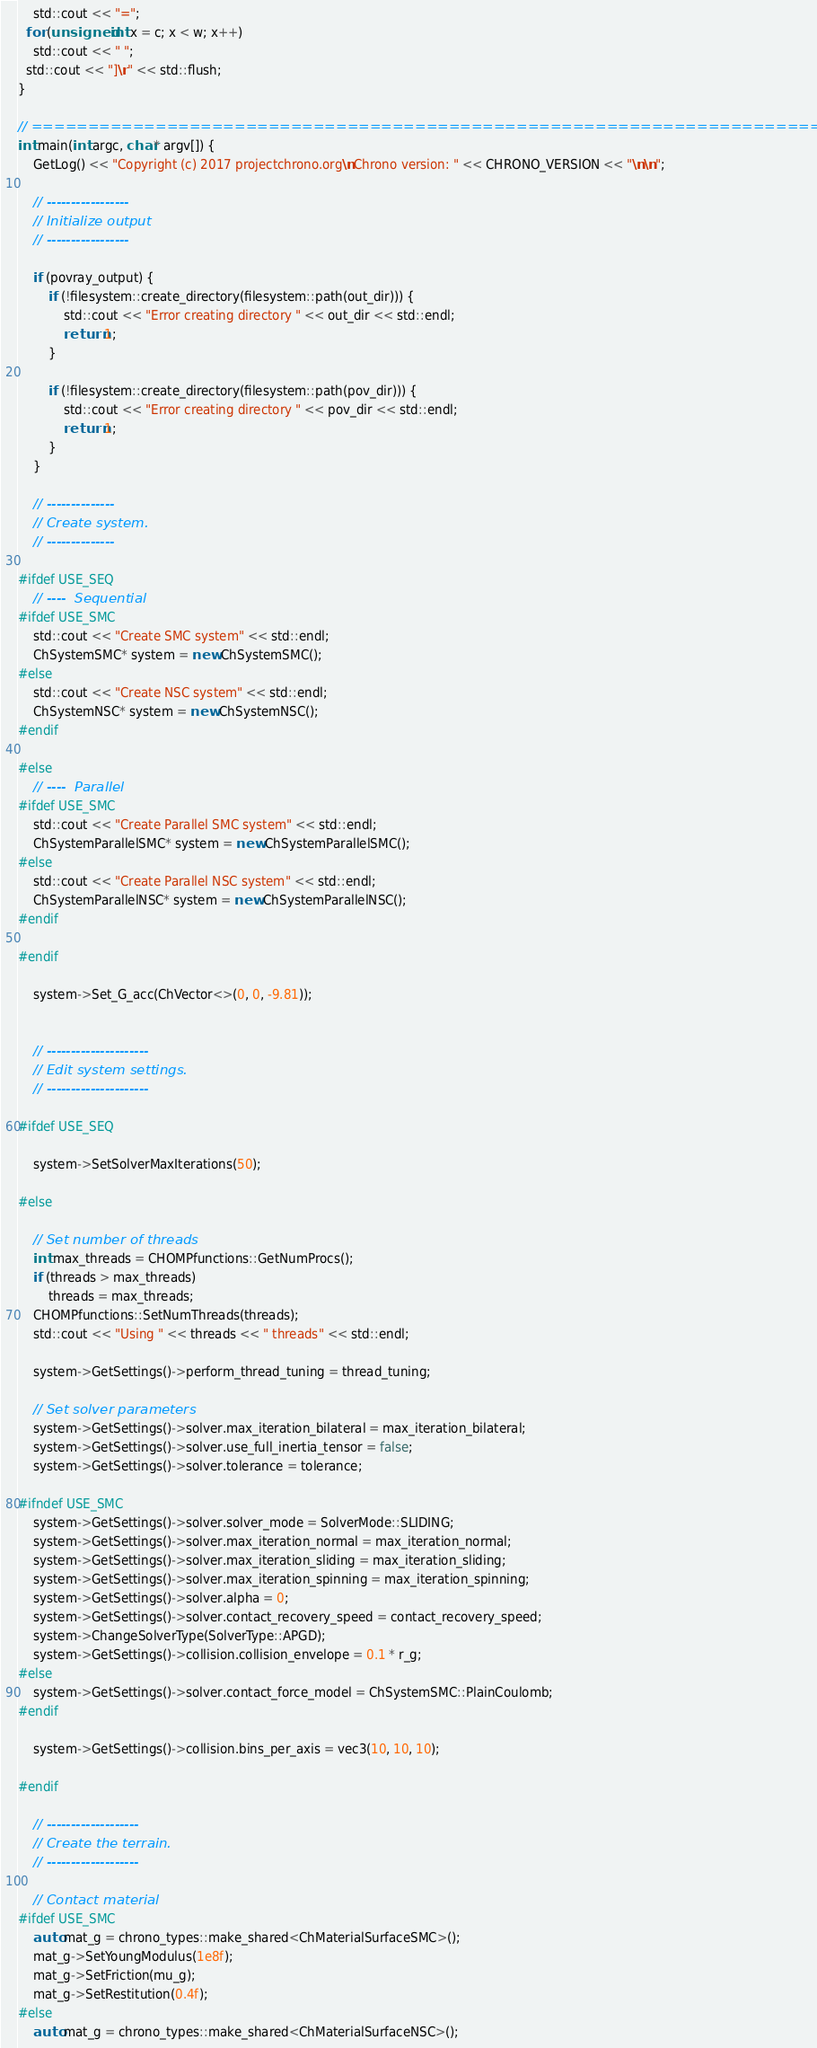<code> <loc_0><loc_0><loc_500><loc_500><_C++_>    std::cout << "=";
  for (unsigned int x = c; x < w; x++)
    std::cout << " ";
  std::cout << "]\r" << std::flush;
}

// =============================================================================
int main(int argc, char* argv[]) {
    GetLog() << "Copyright (c) 2017 projectchrono.org\nChrono version: " << CHRONO_VERSION << "\n\n";

    // -----------------
    // Initialize output
    // -----------------

    if (povray_output) {
        if (!filesystem::create_directory(filesystem::path(out_dir))) {
            std::cout << "Error creating directory " << out_dir << std::endl;
            return 1;
        }

        if (!filesystem::create_directory(filesystem::path(pov_dir))) {
            std::cout << "Error creating directory " << pov_dir << std::endl;
            return 1;
        }
    }

    // --------------
    // Create system.
    // --------------

#ifdef USE_SEQ
    // ----  Sequential
#ifdef USE_SMC
    std::cout << "Create SMC system" << std::endl;
    ChSystemSMC* system = new ChSystemSMC();
#else
    std::cout << "Create NSC system" << std::endl;
    ChSystemNSC* system = new ChSystemNSC();
#endif

#else
    // ----  Parallel
#ifdef USE_SMC
    std::cout << "Create Parallel SMC system" << std::endl;
    ChSystemParallelSMC* system = new ChSystemParallelSMC();
#else
    std::cout << "Create Parallel NSC system" << std::endl;
    ChSystemParallelNSC* system = new ChSystemParallelNSC();
#endif

#endif

    system->Set_G_acc(ChVector<>(0, 0, -9.81));


    // ---------------------
    // Edit system settings.
    // ---------------------

#ifdef USE_SEQ

    system->SetSolverMaxIterations(50);

#else

    // Set number of threads
    int max_threads = CHOMPfunctions::GetNumProcs();
    if (threads > max_threads)
        threads = max_threads;
    CHOMPfunctions::SetNumThreads(threads);
    std::cout << "Using " << threads << " threads" << std::endl;

    system->GetSettings()->perform_thread_tuning = thread_tuning;

    // Set solver parameters
    system->GetSettings()->solver.max_iteration_bilateral = max_iteration_bilateral;
    system->GetSettings()->solver.use_full_inertia_tensor = false;
    system->GetSettings()->solver.tolerance = tolerance;

#ifndef USE_SMC
    system->GetSettings()->solver.solver_mode = SolverMode::SLIDING;
    system->GetSettings()->solver.max_iteration_normal = max_iteration_normal;
    system->GetSettings()->solver.max_iteration_sliding = max_iteration_sliding;
    system->GetSettings()->solver.max_iteration_spinning = max_iteration_spinning;
    system->GetSettings()->solver.alpha = 0;
    system->GetSettings()->solver.contact_recovery_speed = contact_recovery_speed;
    system->ChangeSolverType(SolverType::APGD);
    system->GetSettings()->collision.collision_envelope = 0.1 * r_g;
#else
    system->GetSettings()->solver.contact_force_model = ChSystemSMC::PlainCoulomb;
#endif

    system->GetSettings()->collision.bins_per_axis = vec3(10, 10, 10);

#endif

    // -------------------
    // Create the terrain.
    // -------------------

    // Contact material
#ifdef USE_SMC
    auto mat_g = chrono_types::make_shared<ChMaterialSurfaceSMC>();
    mat_g->SetYoungModulus(1e8f);
    mat_g->SetFriction(mu_g);
    mat_g->SetRestitution(0.4f);
#else
    auto mat_g = chrono_types::make_shared<ChMaterialSurfaceNSC>();</code> 